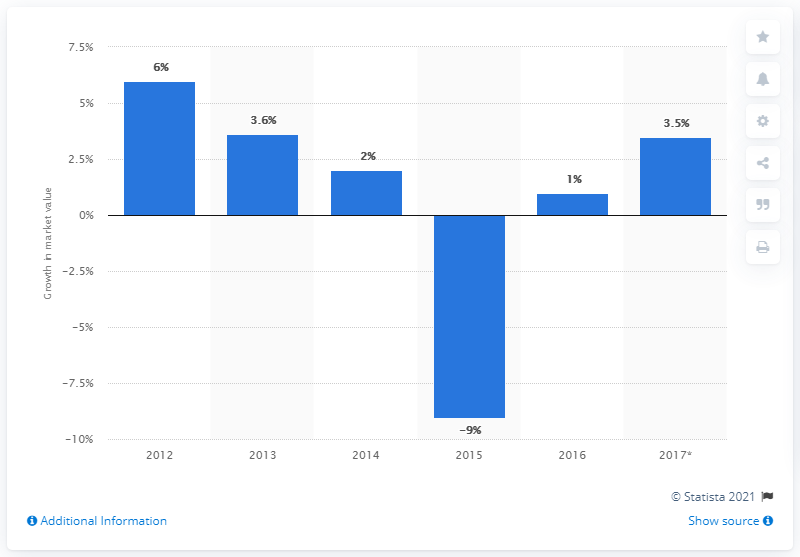Highlight a few significant elements in this photo. The fashion market is forecasted to have grown by approximately 3.5% in 2017, according to estimates. 